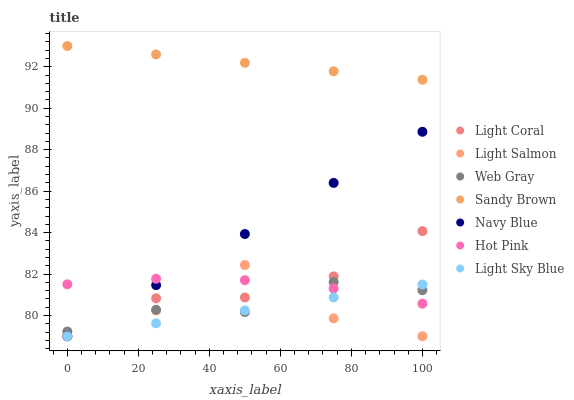Does Light Sky Blue have the minimum area under the curve?
Answer yes or no. Yes. Does Sandy Brown have the maximum area under the curve?
Answer yes or no. Yes. Does Web Gray have the minimum area under the curve?
Answer yes or no. No. Does Web Gray have the maximum area under the curve?
Answer yes or no. No. Is Sandy Brown the smoothest?
Answer yes or no. Yes. Is Light Salmon the roughest?
Answer yes or no. Yes. Is Web Gray the smoothest?
Answer yes or no. No. Is Web Gray the roughest?
Answer yes or no. No. Does Light Salmon have the lowest value?
Answer yes or no. Yes. Does Web Gray have the lowest value?
Answer yes or no. No. Does Sandy Brown have the highest value?
Answer yes or no. Yes. Does Web Gray have the highest value?
Answer yes or no. No. Is Light Sky Blue less than Sandy Brown?
Answer yes or no. Yes. Is Sandy Brown greater than Light Sky Blue?
Answer yes or no. Yes. Does Hot Pink intersect Light Salmon?
Answer yes or no. Yes. Is Hot Pink less than Light Salmon?
Answer yes or no. No. Is Hot Pink greater than Light Salmon?
Answer yes or no. No. Does Light Sky Blue intersect Sandy Brown?
Answer yes or no. No. 